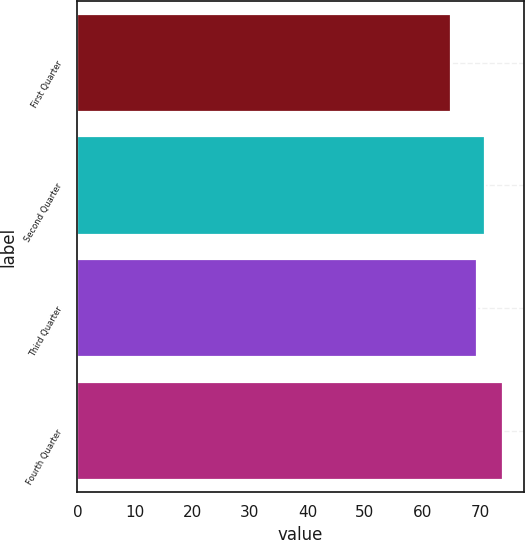Convert chart. <chart><loc_0><loc_0><loc_500><loc_500><bar_chart><fcel>First Quarter<fcel>Second Quarter<fcel>Third Quarter<fcel>Fourth Quarter<nl><fcel>64.95<fcel>70.89<fcel>69.5<fcel>73.94<nl></chart> 